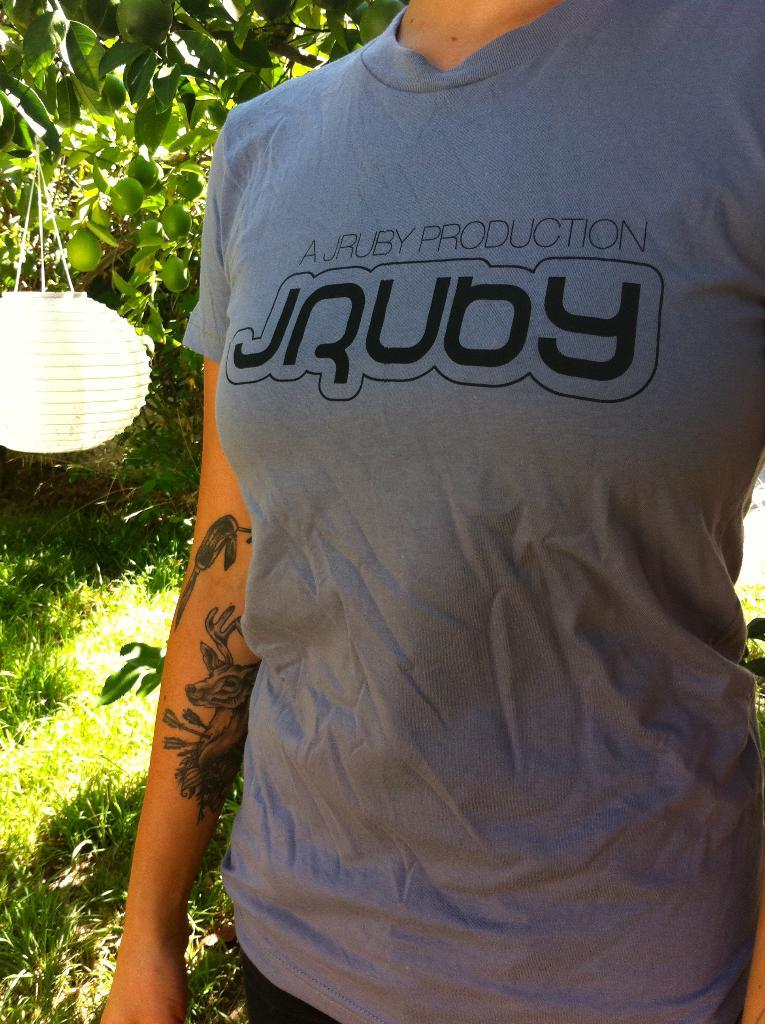Who or what is present in the image? There is a person in the image. What is located near the person? There is a light beside the person. What can be seen in the background of the image? There are trees and grass in the background of the image. What type of hole can be seen in the image? There is no hole present in the image. What time is it according to the watch in the image? There is no watch present in the image. 